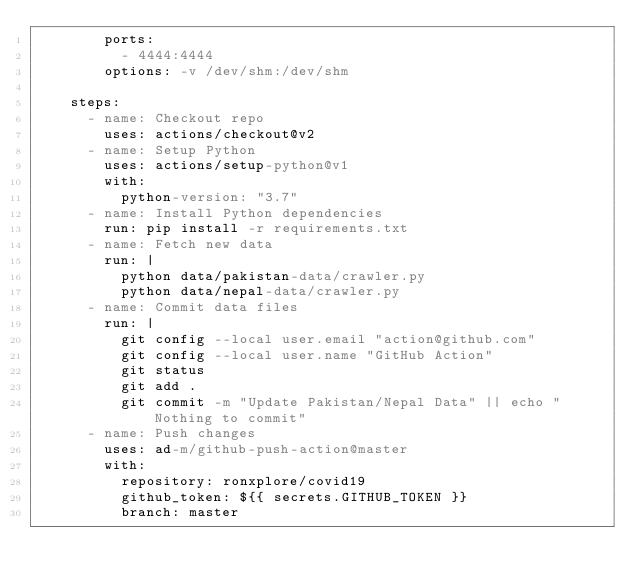<code> <loc_0><loc_0><loc_500><loc_500><_YAML_>        ports:
          - 4444:4444
        options: -v /dev/shm:/dev/shm

    steps:
      - name: Checkout repo
        uses: actions/checkout@v2
      - name: Setup Python
        uses: actions/setup-python@v1
        with:
          python-version: "3.7"
      - name: Install Python dependencies
        run: pip install -r requirements.txt
      - name: Fetch new data
        run: |
          python data/pakistan-data/crawler.py
          python data/nepal-data/crawler.py
      - name: Commit data files
        run: |
          git config --local user.email "action@github.com"
          git config --local user.name "GitHub Action"
          git status
          git add .
          git commit -m "Update Pakistan/Nepal Data" || echo "Nothing to commit"
      - name: Push changes
        uses: ad-m/github-push-action@master
        with:
          repository: ronxplore/covid19
          github_token: ${{ secrets.GITHUB_TOKEN }}
          branch: master
</code> 